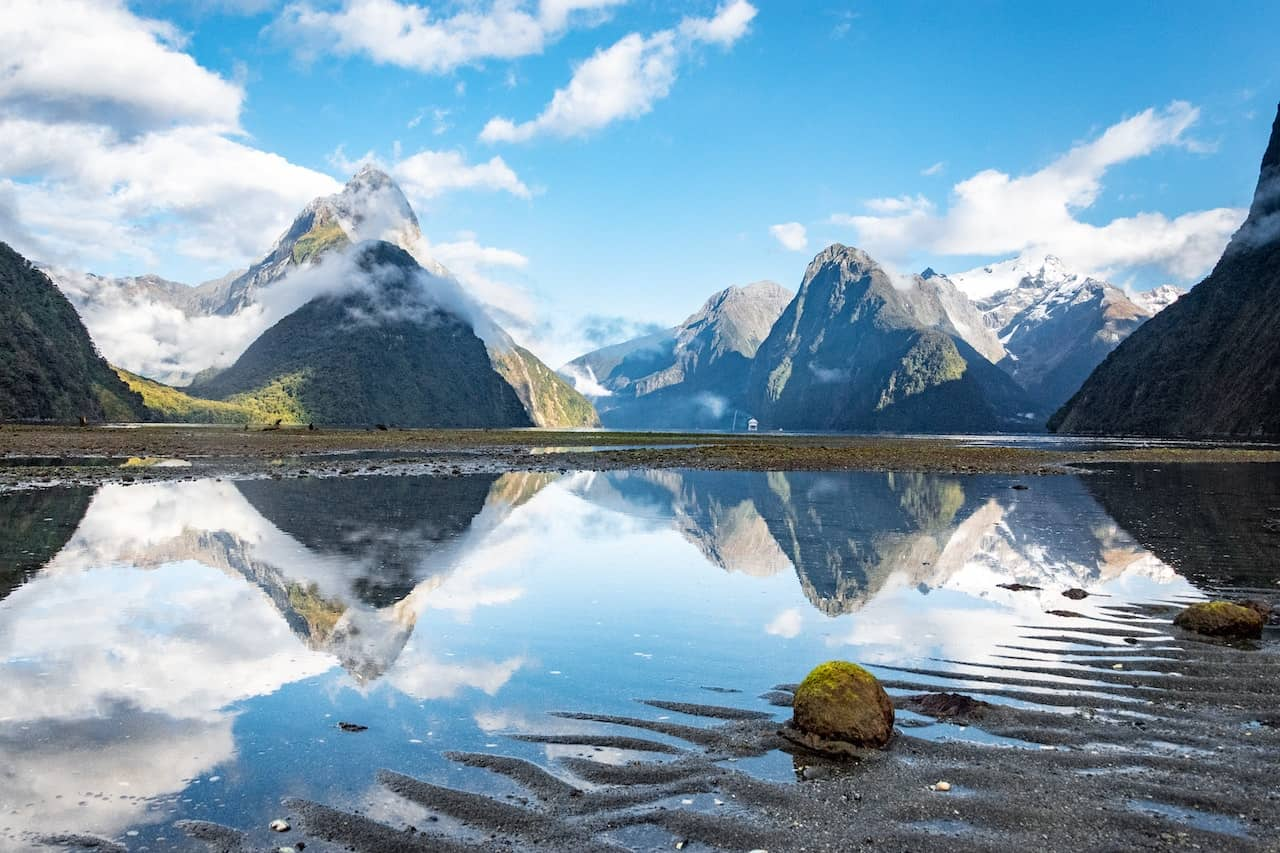Describe the following image. The image depicts the sublime beauty of Milford Sound in New Zealand, characterized by its dramatic landscape. From a vantage point near the water's edge, we see towering mountains with sharply defined peaks, partially shrouded by mist, rising imposingly above the landscape. The peaks are capped with snow, providing a stark contrast to the lush greenery cloaking the lower slopes. The sky above is a canvass of vibrant blue, littered with wisps of white clouds that enhance the vividness of the panorama. Below, the calm waters serve as a mirror, reflecting the mountains and sky in a flawless symmetrical display. This near-perfect reflection is only gently disrupted by light ripples, adding texture to the scene. Foreground details include a rocky shoreline scattered with green moss and small puddles, reminding us of the untouched, serene nature of this remote locale. This image is not only a visual feast but also invokes a sense of tranquility and awe, characteristic of New Zealand's pristine wilderness. 